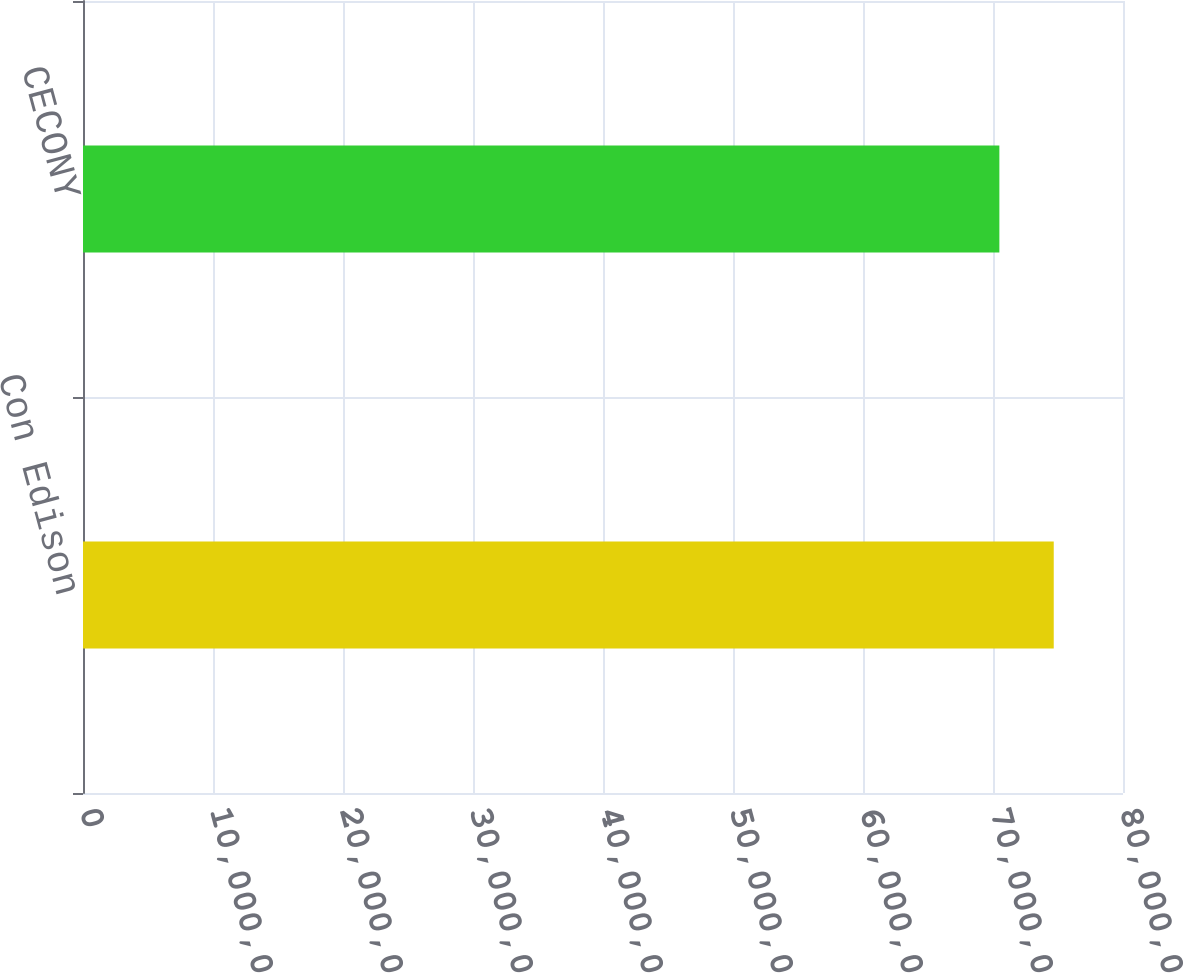Convert chart to OTSL. <chart><loc_0><loc_0><loc_500><loc_500><bar_chart><fcel>Con Edison<fcel>CECONY<nl><fcel>7.46722e+07<fcel>7.049e+07<nl></chart> 